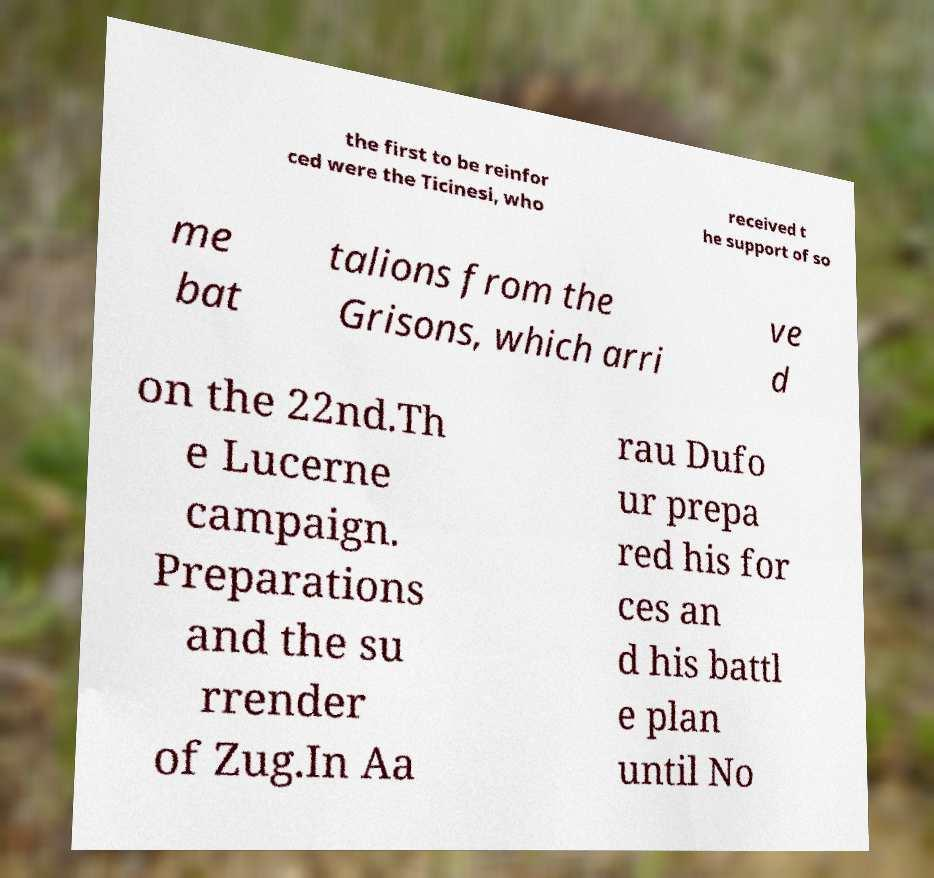What messages or text are displayed in this image? I need them in a readable, typed format. the first to be reinfor ced were the Ticinesi, who received t he support of so me bat talions from the Grisons, which arri ve d on the 22nd.Th e Lucerne campaign. Preparations and the su rrender of Zug.In Aa rau Dufo ur prepa red his for ces an d his battl e plan until No 